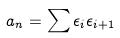<formula> <loc_0><loc_0><loc_500><loc_500>a _ { n } = \sum \epsilon _ { i } \epsilon _ { i + 1 }</formula> 